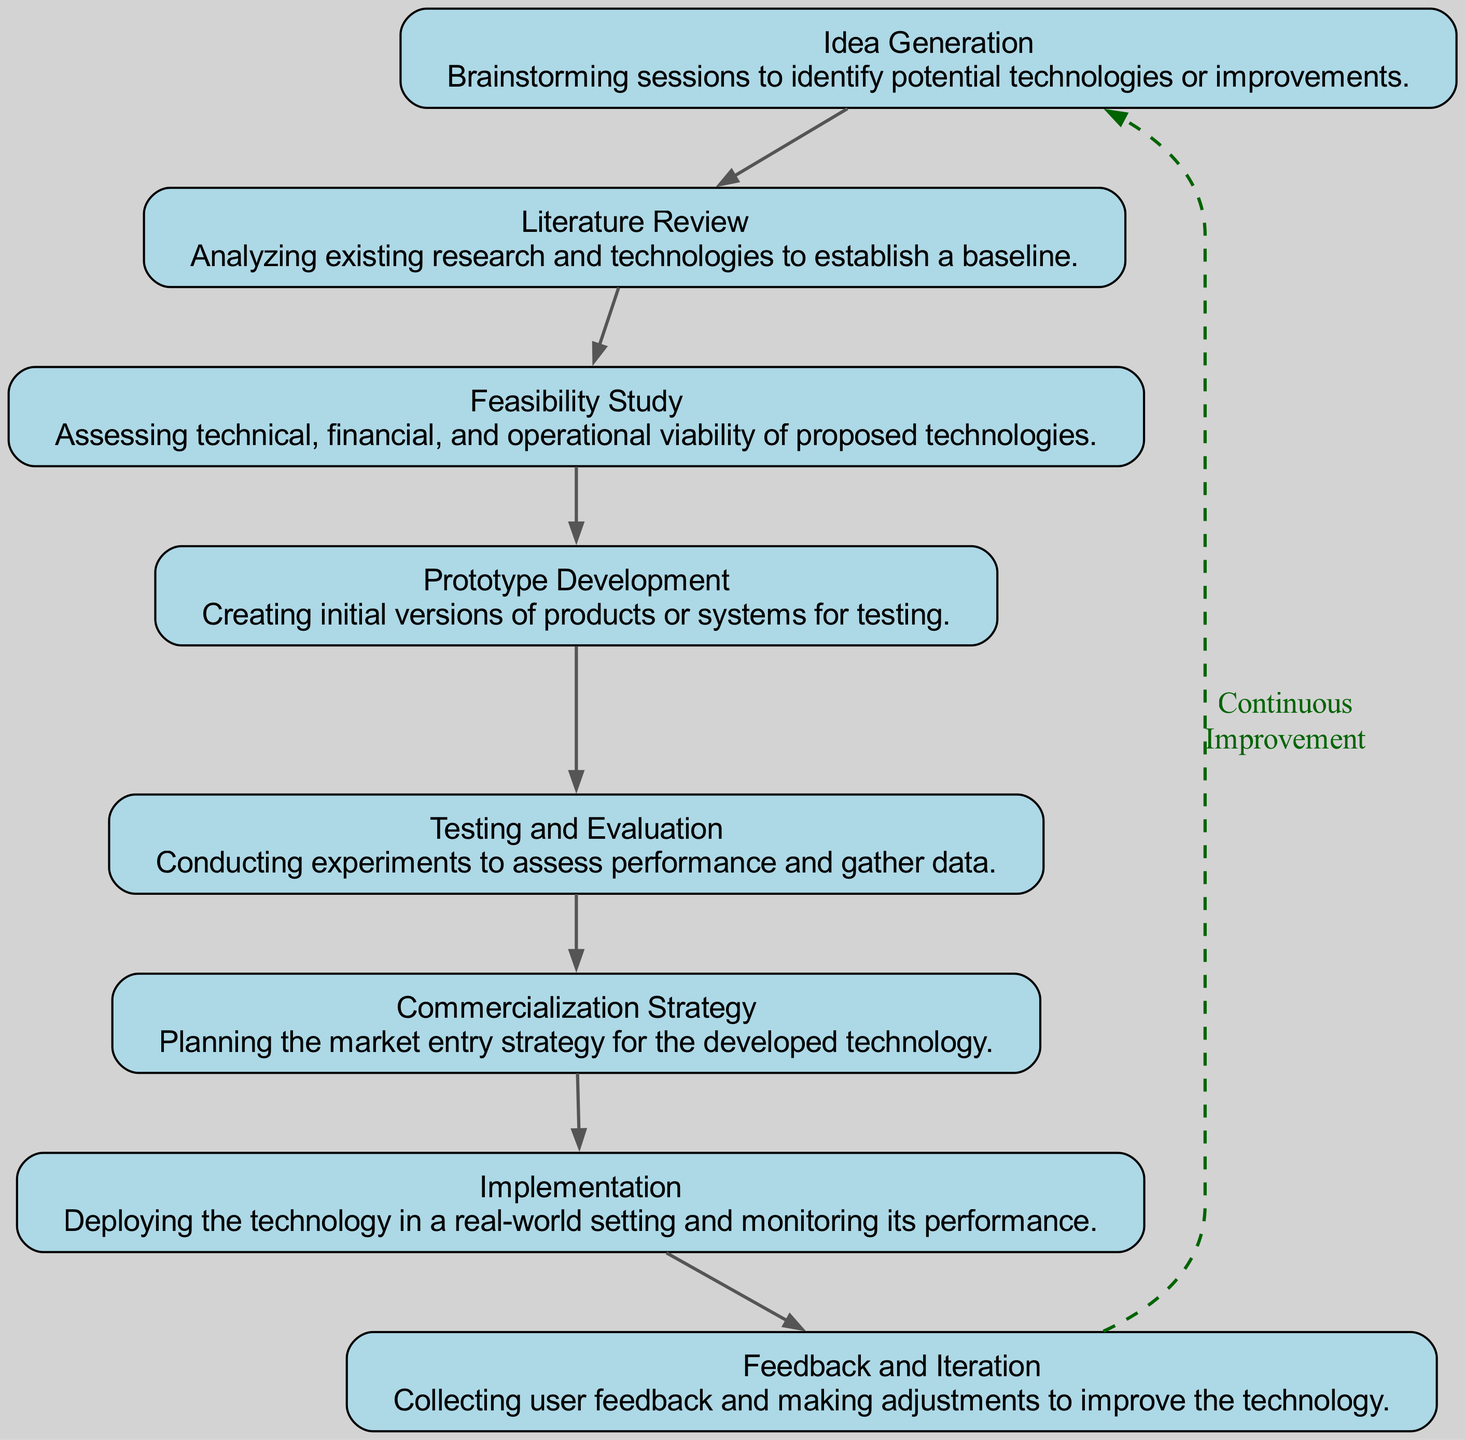What is the first step in the R&D process? The diagram shows that the first step is labeled as "Idea Generation," indicating that this is where the process begins.
Answer: Idea Generation How many steps are detailed in the R&D process? By counting the numbered nodes in the diagram, there is a total of 8 steps listed from 1 to 8.
Answer: 8 What is the last step before commercialization? The step just before the "Commercialization Strategy" is "Testing and Evaluation," as indicated by the flow connecting these two nodes.
Answer: Testing and Evaluation Which step involves user feedback? The step that specifically mentions collecting user feedback is "Feedback and Iteration," which is clearly labeled in the diagram.
Answer: Feedback and Iteration What type of study assesses the viability of proposed technologies? The diagram identifies "Feasibility Study" as the step aimed at assessing technical, financial, and operational viability.
Answer: Feasibility Study What does the dashed edge connecting the last node to the first represent? The dashed edge with the label "Continuous Improvement" indicates that after completing the final step, the process returns to "Idea Generation" for ongoing development.
Answer: Continuous Improvement How many edges are there in the flowchart? Each step is connected sequentially, adding one edge for each connection, resulting in 8 edges for the 8 steps, plus one dashed edge for continuous improvement, which totals 9 edges.
Answer: 9 What is the main focus of the "Prototype Development" step? This step focuses on creating initial versions of products or systems for testing, as described in the corresponding node in the diagram.
Answer: Creating initial versions What is the purpose of the "Commercialization Strategy"? The purpose is to plan the market entry strategy for the developed technology, which is specifically stated in the node related to this step.
Answer: Planning market entry strategy 